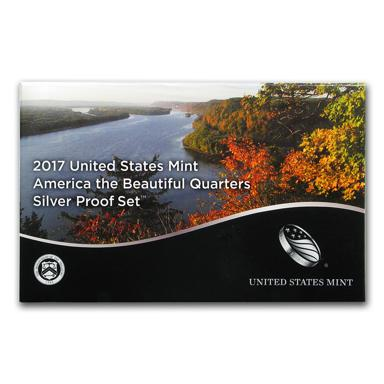Can you tell more about one of the quarters included in the 2017 Silver Proof Set? Certainly! One of the quarters in the 2017 Silver Proof Set features Ellis Island National Monument in New Jersey. This quarter depicts an immigrant family approaching Ellis Island, symbolizing the many dreams and stories of those who passed through as they entered the United States, looking for a new beginning. 